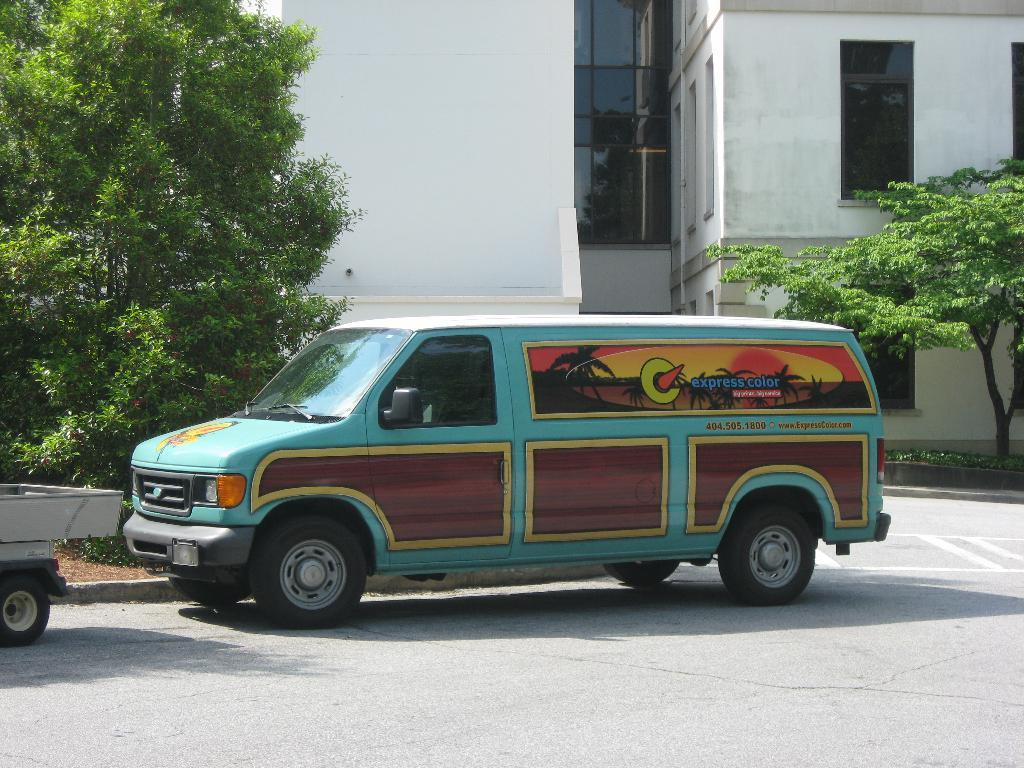What can be seen on the road in the image? There are vehicles on the road in the image. What type of natural elements are visible in the image? There are trees visible in the image. What type of structure can be seen in the background of the image? There is a building with windows in the background of the image. What news headline is displayed on the building in the image? There is no news headline visible on the building in the image. Can you see any bats flying around in the image? There are no bats present in the image. 